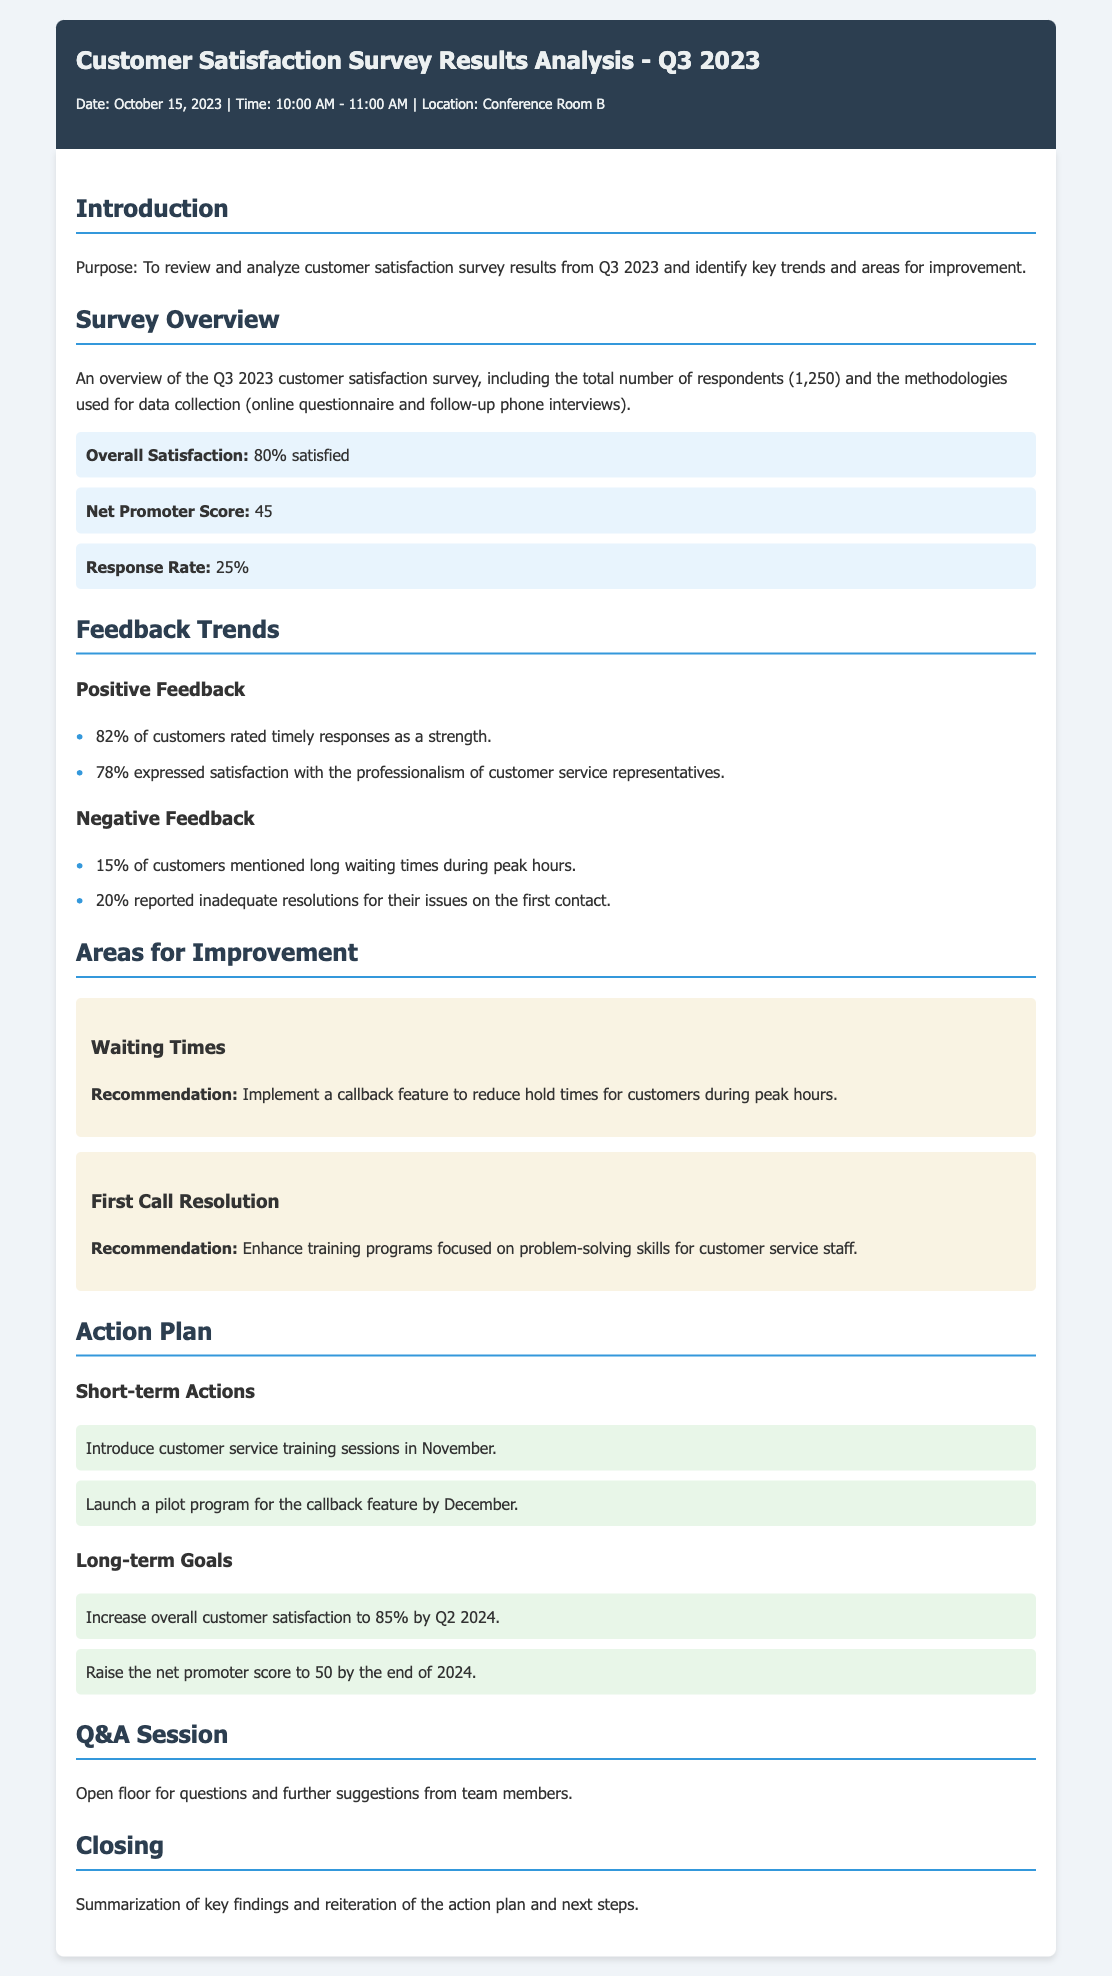What is the overall satisfaction percentage? The overall satisfaction is stated in the survey overview section as being 80%.
Answer: 80% How many respondents participated in the survey? The total number of respondents is mentioned as 1,250 in the survey overview section.
Answer: 1,250 What percentage of customers rated timely responses positively? This information is found under positive feedback, where it states that 82% of customers rated timely responses as a strength.
Answer: 82% What is the Net Promoter Score reported for Q3 2023? The Net Promoter Score is highlighted in the survey overview section as 45.
Answer: 45 What area received a recommendation for a callback feature? The waiting times section suggests implementing a callback feature to reduce hold times for customers.
Answer: Waiting Times How many actions are listed under short-term actions? The action plan section includes two specific short-term actions introduced for improvement.
Answer: 2 What is the target overall customer satisfaction percentage by Q2 2024? The long-term goals section specifies aiming to increase overall customer satisfaction to 85% by Q2 2024.
Answer: 85% What percentage of customers expressed dissatisfaction with the first contact resolution? This is mentioned under negative feedback, where it states that 20% reported inadequate resolutions.
Answer: 20% What type of training is recommended for customer service staff? The recommendations outline enhancing training programs focused on problem-solving skills for customer service staff.
Answer: Problem-solving skills 